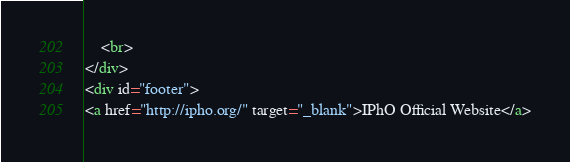Convert code to text. <code><loc_0><loc_0><loc_500><loc_500><_HTML_>    <br>
</div>
<div id="footer">
<a href="http://ipho.org/" target="_blank">IPhO Official Website</a></code> 